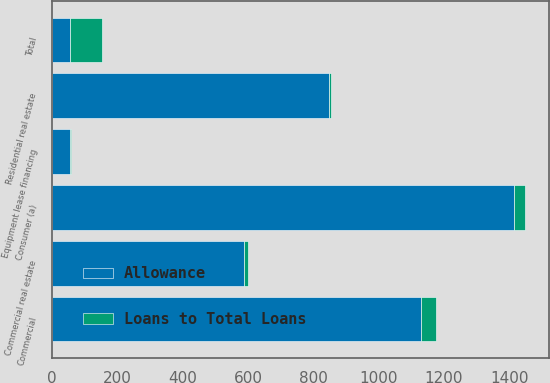<chart> <loc_0><loc_0><loc_500><loc_500><stacked_bar_chart><ecel><fcel>Commercial<fcel>Commercial real estate<fcel>Equipment lease financing<fcel>Consumer (a)<fcel>Residential real estate<fcel>Total<nl><fcel>Allowance<fcel>1131<fcel>589<fcel>54<fcel>1415<fcel>847<fcel>54<nl><fcel>Loans to Total Loans<fcel>44.7<fcel>10<fcel>3.9<fcel>33.2<fcel>8.2<fcel>100<nl></chart> 